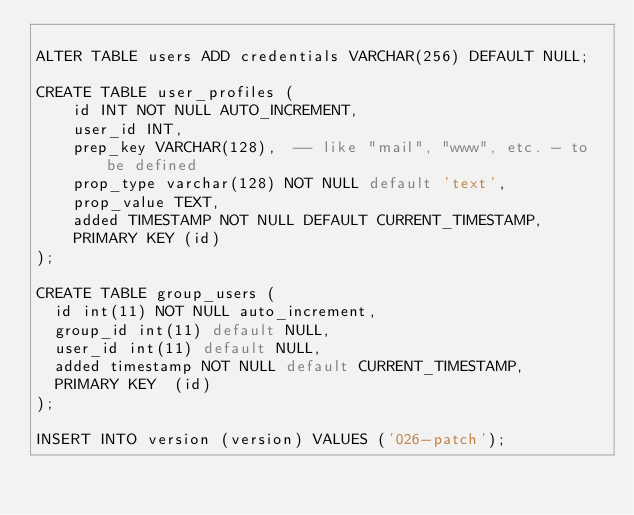Convert code to text. <code><loc_0><loc_0><loc_500><loc_500><_SQL_>
ALTER TABLE users ADD credentials VARCHAR(256) DEFAULT NULL;

CREATE TABLE user_profiles (
    id INT NOT NULL AUTO_INCREMENT,
    user_id INT,
    prep_key VARCHAR(128),  -- like "mail", "www", etc. - to be defined
    prop_type varchar(128) NOT NULL default 'text',
    prop_value TEXT,
    added TIMESTAMP NOT NULL DEFAULT CURRENT_TIMESTAMP,
    PRIMARY KEY (id)
);

CREATE TABLE group_users (
  id int(11) NOT NULL auto_increment,
  group_id int(11) default NULL,
  user_id int(11) default NULL,
  added timestamp NOT NULL default CURRENT_TIMESTAMP,
  PRIMARY KEY  (id)
);

INSERT INTO version (version) VALUES ('026-patch');
</code> 